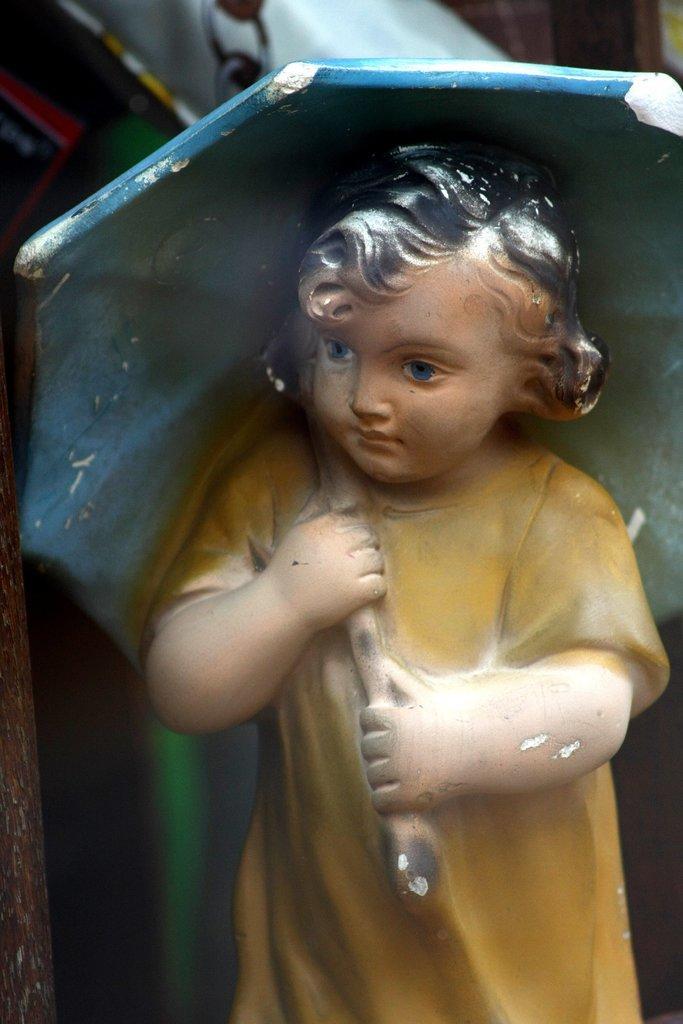Describe this image in one or two sentences. In the image there is an idol of a baby holding an umbrella. 